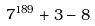<formula> <loc_0><loc_0><loc_500><loc_500>7 ^ { 1 8 9 } + 3 - 8</formula> 